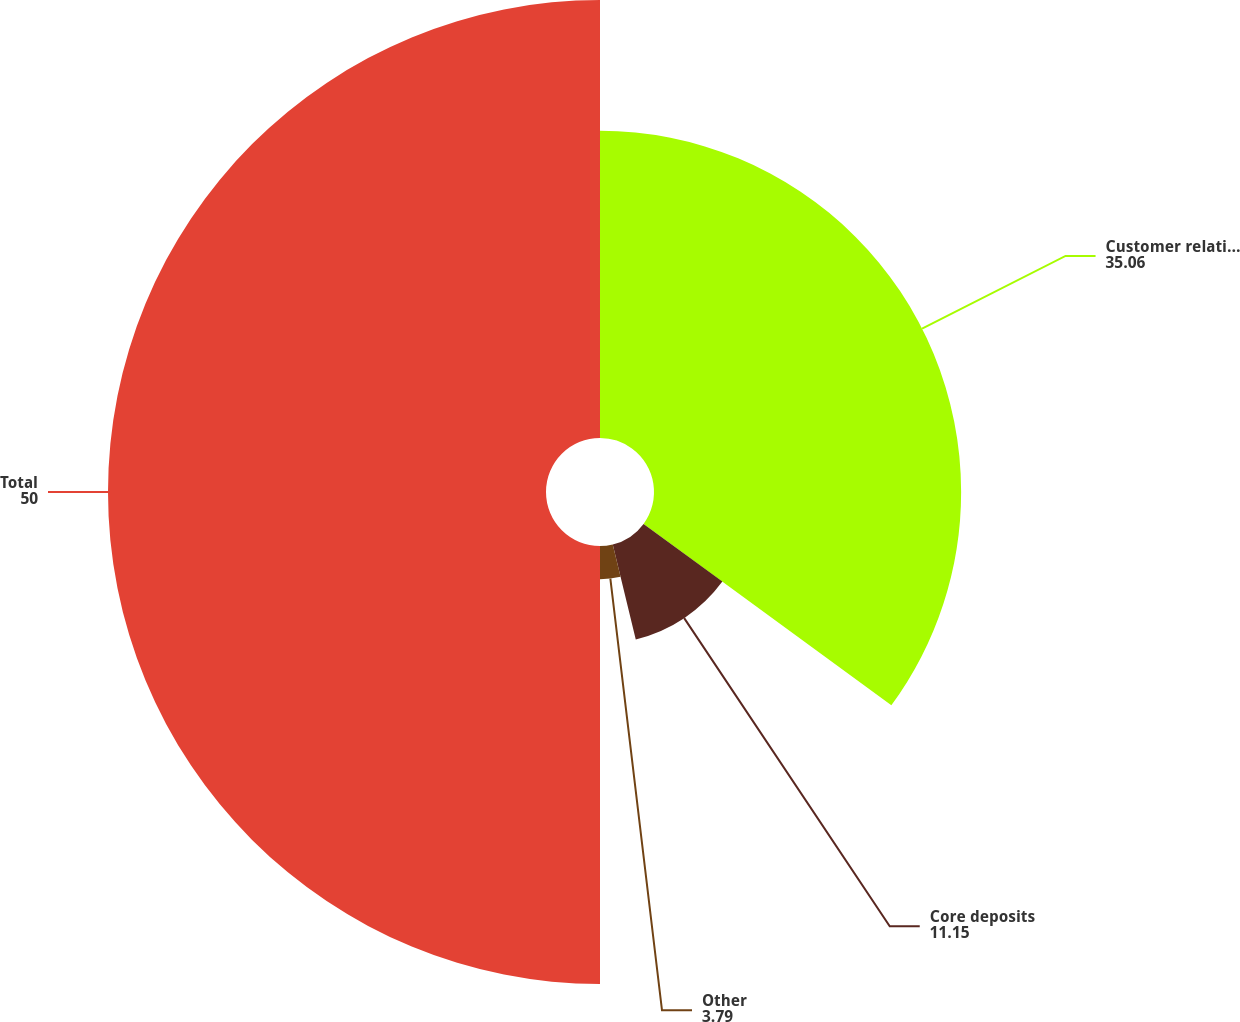Convert chart. <chart><loc_0><loc_0><loc_500><loc_500><pie_chart><fcel>Customer relationships<fcel>Core deposits<fcel>Other<fcel>Total<nl><fcel>35.06%<fcel>11.15%<fcel>3.79%<fcel>50.0%<nl></chart> 